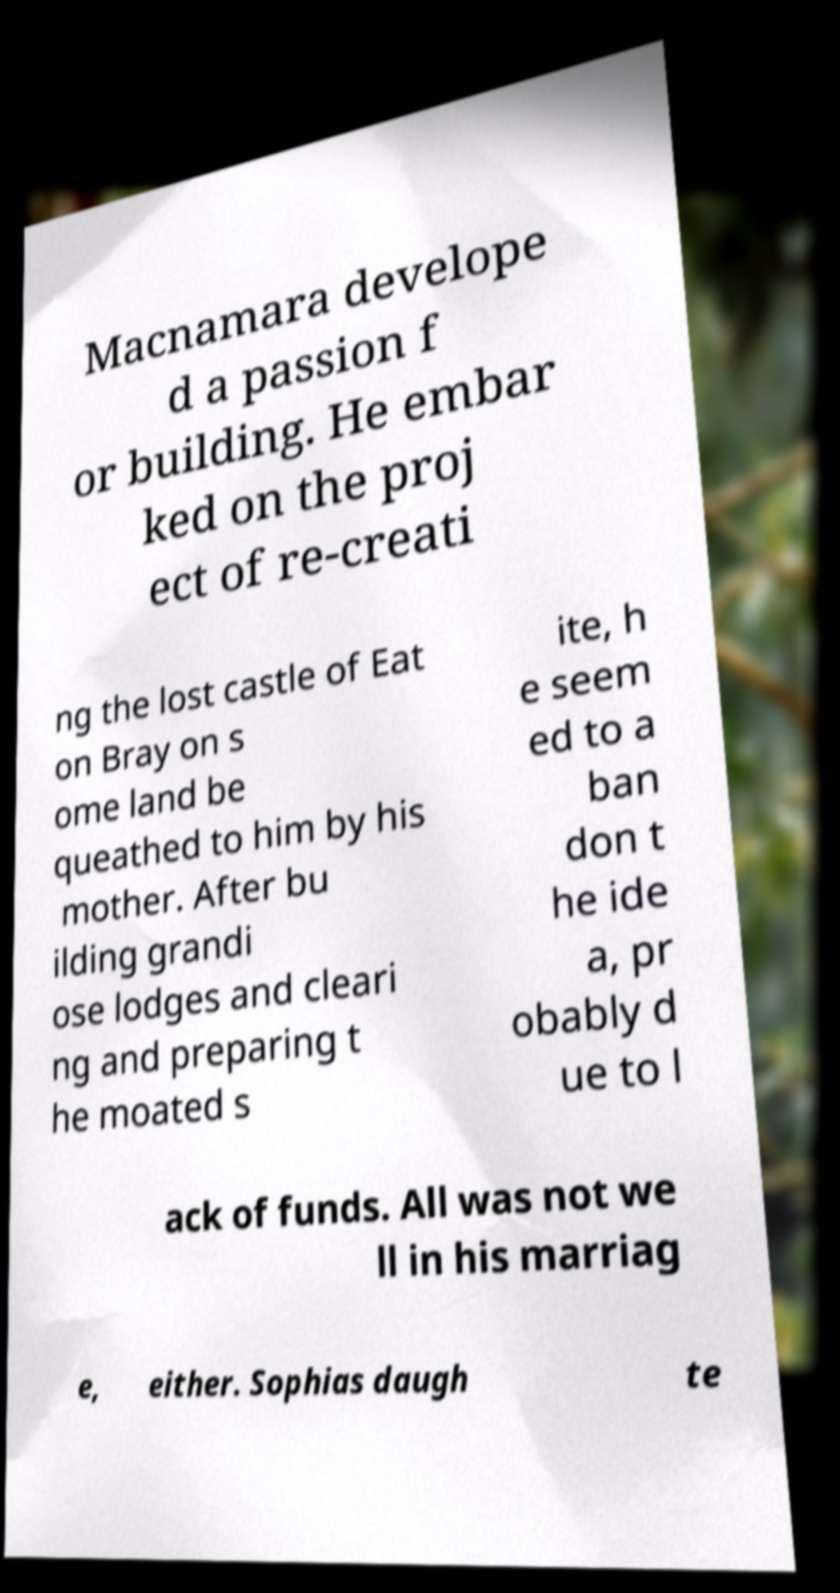What messages or text are displayed in this image? I need them in a readable, typed format. Macnamara develope d a passion f or building. He embar ked on the proj ect of re-creati ng the lost castle of Eat on Bray on s ome land be queathed to him by his mother. After bu ilding grandi ose lodges and cleari ng and preparing t he moated s ite, h e seem ed to a ban don t he ide a, pr obably d ue to l ack of funds. All was not we ll in his marriag e, either. Sophias daugh te 